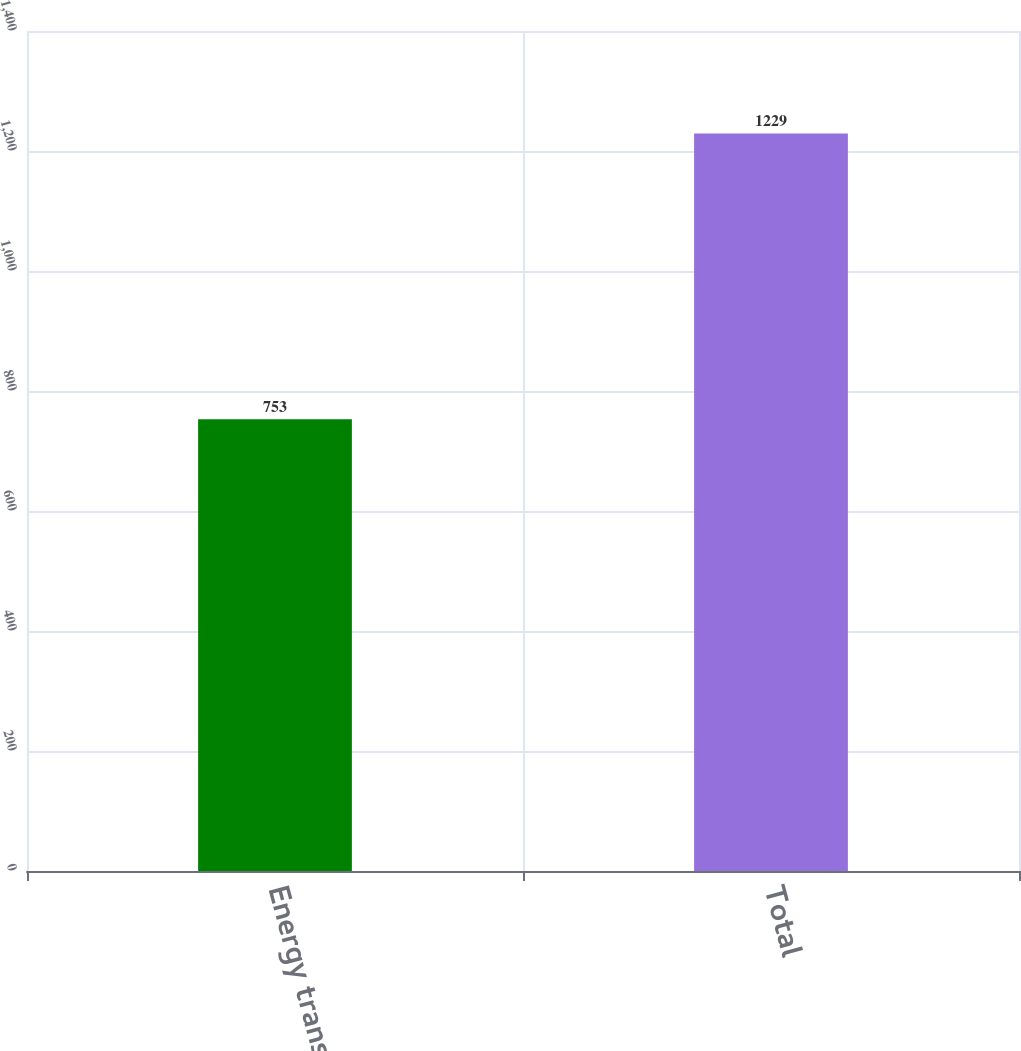Convert chart. <chart><loc_0><loc_0><loc_500><loc_500><bar_chart><fcel>Energy transactions<fcel>Total<nl><fcel>753<fcel>1229<nl></chart> 